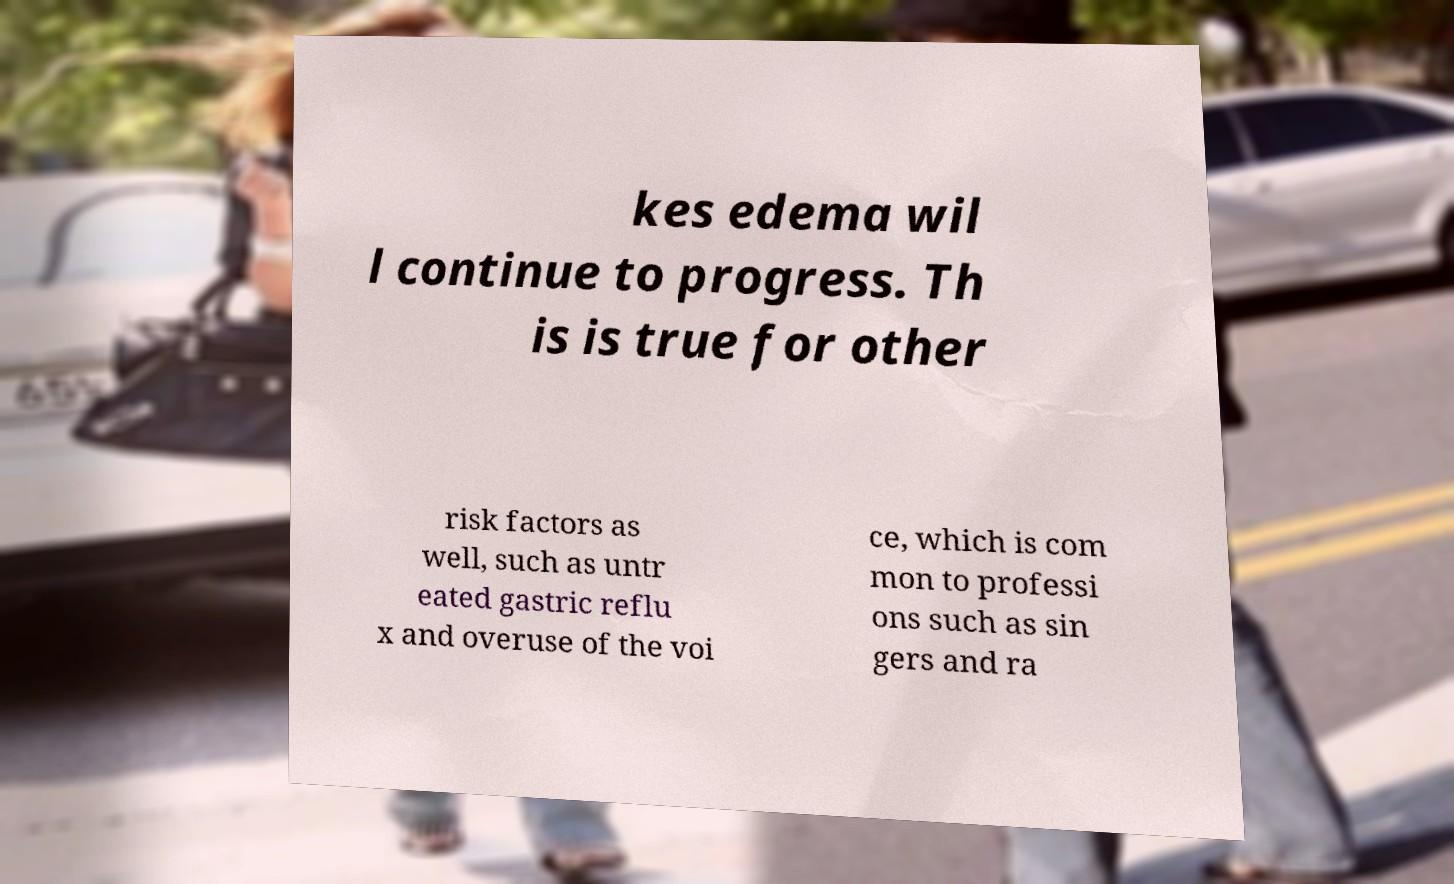For documentation purposes, I need the text within this image transcribed. Could you provide that? kes edema wil l continue to progress. Th is is true for other risk factors as well, such as untr eated gastric reflu x and overuse of the voi ce, which is com mon to professi ons such as sin gers and ra 